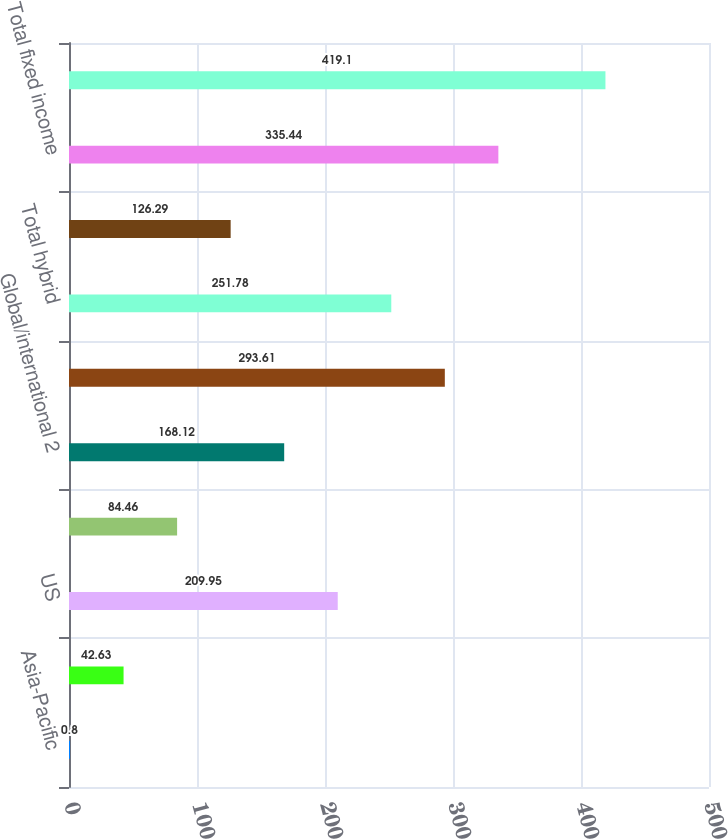Convert chart. <chart><loc_0><loc_0><loc_500><loc_500><bar_chart><fcel>Asia-Pacific<fcel>Europe the Middle East and<fcel>US<fcel>Emerging markets 1<fcel>Global/international 2<fcel>Total equity<fcel>Total hybrid<fcel>US taxable<fcel>Total fixed income<fcel>Total<nl><fcel>0.8<fcel>42.63<fcel>209.95<fcel>84.46<fcel>168.12<fcel>293.61<fcel>251.78<fcel>126.29<fcel>335.44<fcel>419.1<nl></chart> 